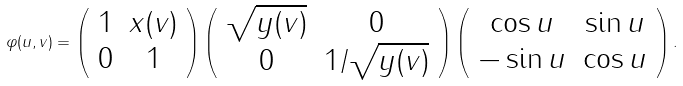Convert formula to latex. <formula><loc_0><loc_0><loc_500><loc_500>\varphi ( u , v ) = \left ( \begin{array} { c c } 1 & x ( v ) \\ 0 & 1 \end{array} \right ) \left ( \begin{array} { c c } \sqrt { y ( v ) } & 0 \\ 0 & 1 / \sqrt { y ( v ) } \end{array} \right ) \left ( \begin{array} { c c } \cos u & \sin u \\ - \sin u & \cos u \end{array} \right ) .</formula> 